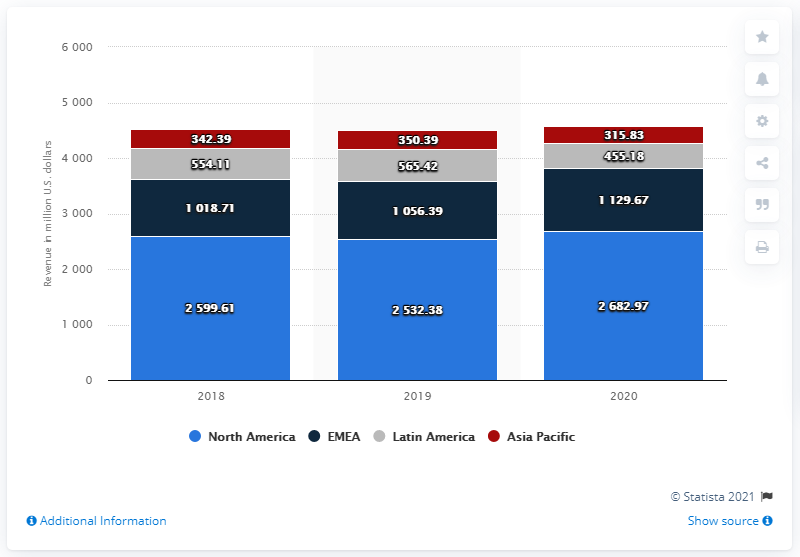Outline some significant characteristics in this image. Mattel generated a revenue of 315.83 million in Asia Pacific in 2020. 